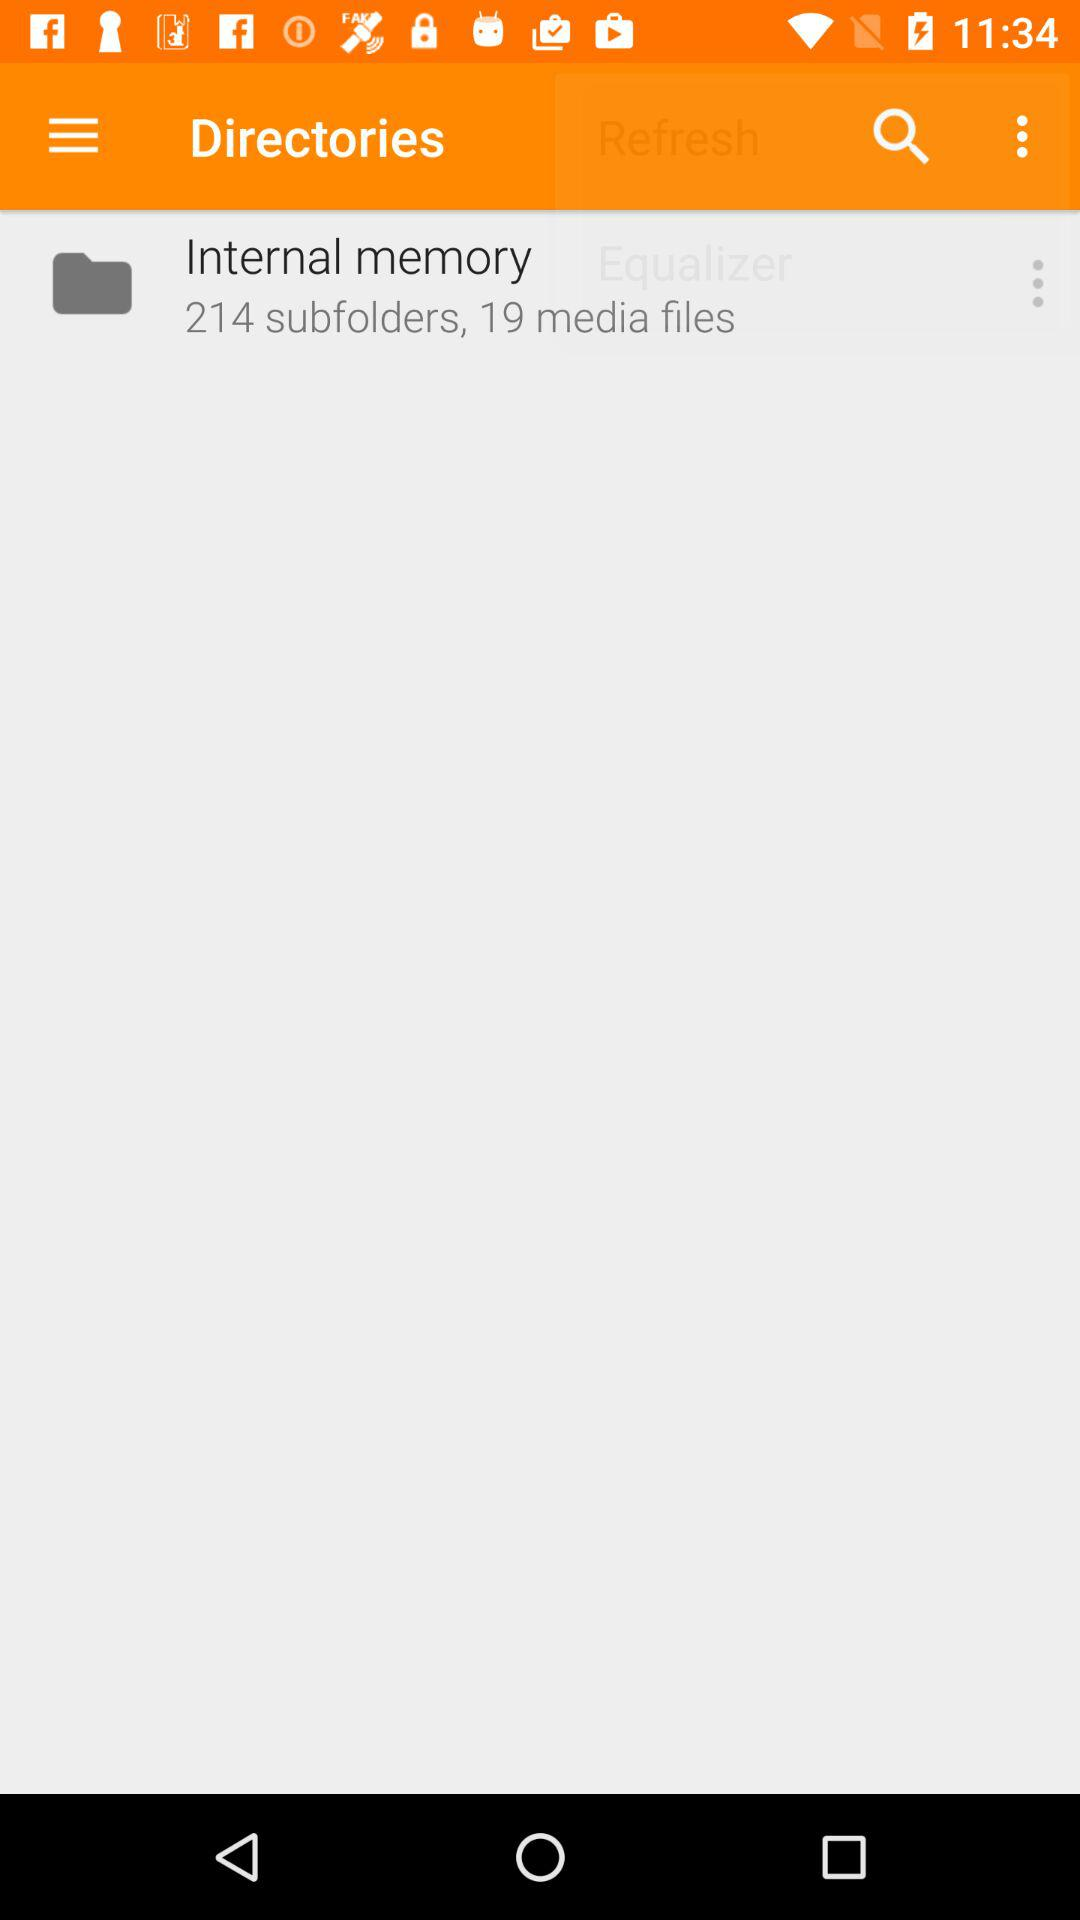How many subfolders are there in the internal memory?
Answer the question using a single word or phrase. 214 